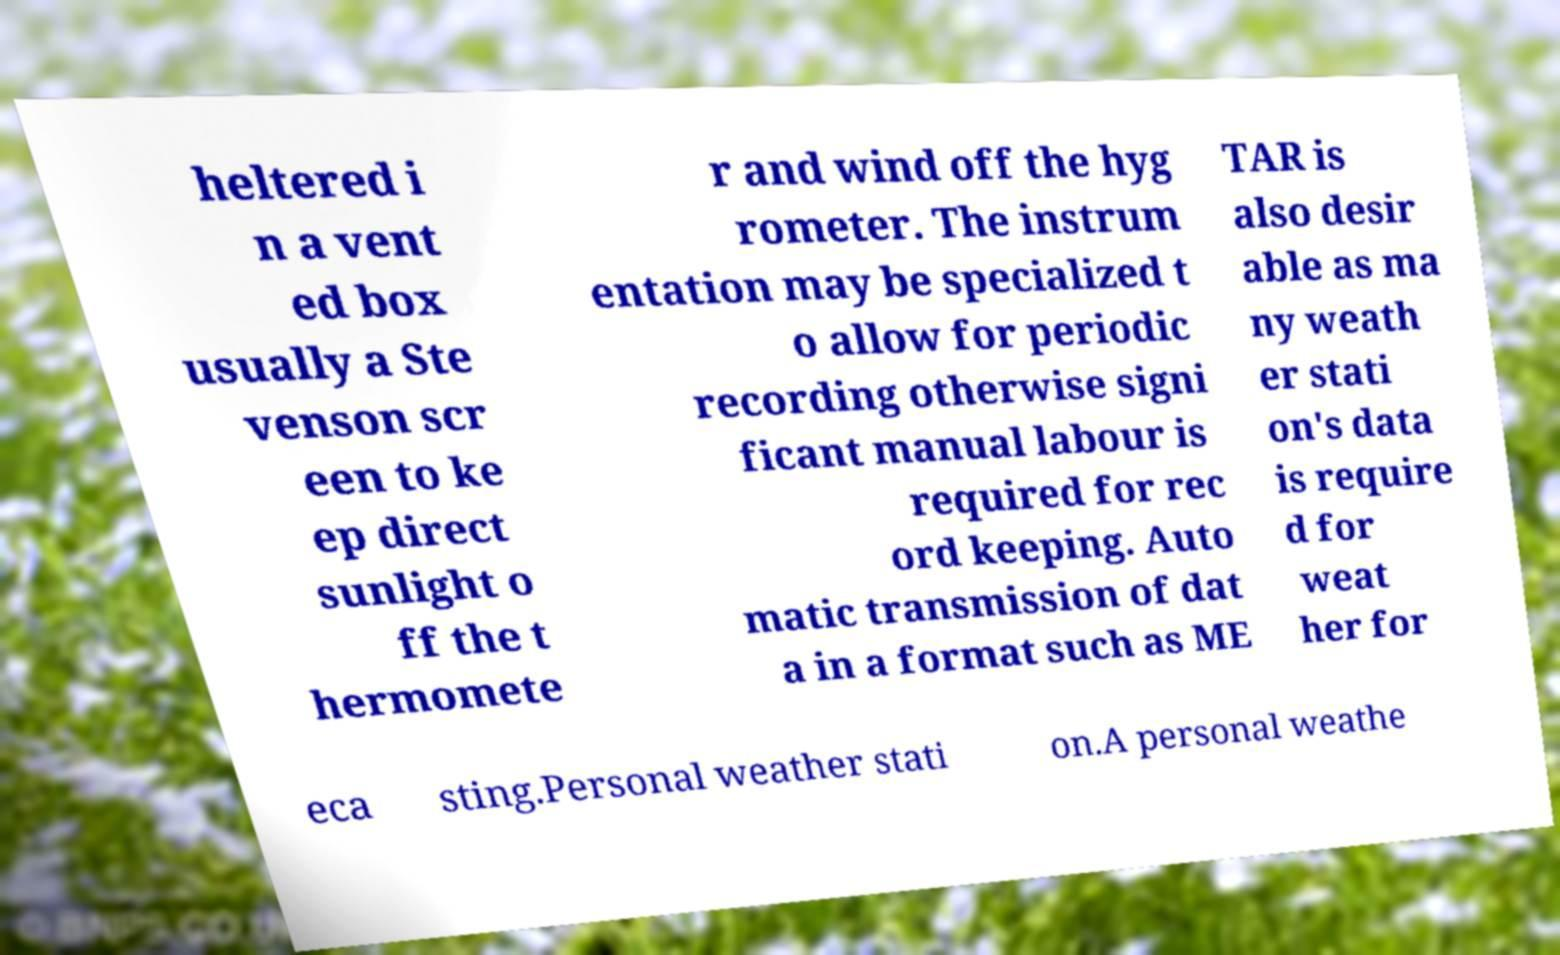What messages or text are displayed in this image? I need them in a readable, typed format. heltered i n a vent ed box usually a Ste venson scr een to ke ep direct sunlight o ff the t hermomete r and wind off the hyg rometer. The instrum entation may be specialized t o allow for periodic recording otherwise signi ficant manual labour is required for rec ord keeping. Auto matic transmission of dat a in a format such as ME TAR is also desir able as ma ny weath er stati on's data is require d for weat her for eca sting.Personal weather stati on.A personal weathe 